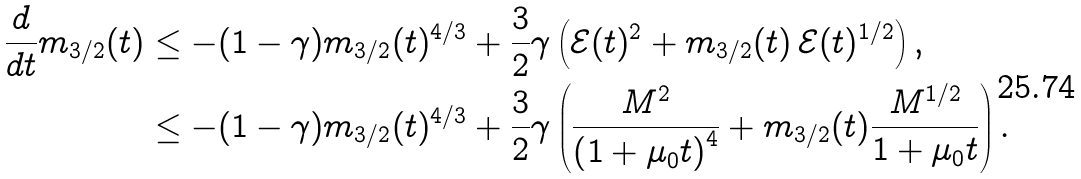<formula> <loc_0><loc_0><loc_500><loc_500>\frac { d } { d t } m _ { 3 / 2 } ( t ) & \leq - ( 1 - \gamma ) m _ { 3 / 2 } ( t ) ^ { 4 / 3 } + \frac { 3 } { 2 } \gamma \left ( \mathcal { E } ( t ) ^ { 2 } + m _ { 3 / 2 } ( t ) \, \mathcal { E } ( t ) ^ { 1 / 2 } \right ) , \\ & \leq - ( 1 - \gamma ) m _ { 3 / 2 } ( t ) ^ { 4 / 3 } + \frac { 3 } { 2 } \gamma \left ( \frac { M ^ { 2 } } { \left ( 1 + \mu _ { 0 } t \right ) ^ { 4 } } + m _ { 3 / 2 } ( t ) \frac { M ^ { 1 / 2 } } { 1 + \mu _ { 0 } t } \right ) .</formula> 